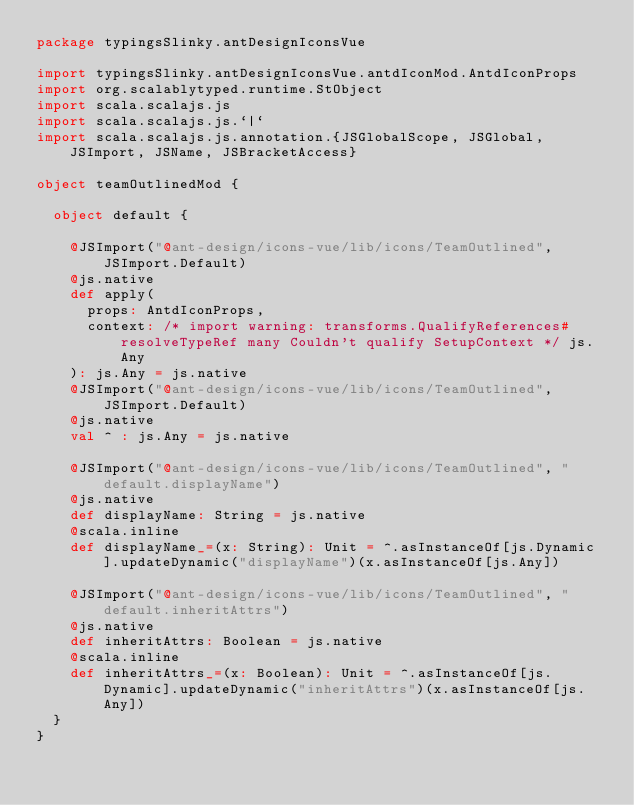Convert code to text. <code><loc_0><loc_0><loc_500><loc_500><_Scala_>package typingsSlinky.antDesignIconsVue

import typingsSlinky.antDesignIconsVue.antdIconMod.AntdIconProps
import org.scalablytyped.runtime.StObject
import scala.scalajs.js
import scala.scalajs.js.`|`
import scala.scalajs.js.annotation.{JSGlobalScope, JSGlobal, JSImport, JSName, JSBracketAccess}

object teamOutlinedMod {
  
  object default {
    
    @JSImport("@ant-design/icons-vue/lib/icons/TeamOutlined", JSImport.Default)
    @js.native
    def apply(
      props: AntdIconProps,
      context: /* import warning: transforms.QualifyReferences#resolveTypeRef many Couldn't qualify SetupContext */ js.Any
    ): js.Any = js.native
    @JSImport("@ant-design/icons-vue/lib/icons/TeamOutlined", JSImport.Default)
    @js.native
    val ^ : js.Any = js.native
    
    @JSImport("@ant-design/icons-vue/lib/icons/TeamOutlined", "default.displayName")
    @js.native
    def displayName: String = js.native
    @scala.inline
    def displayName_=(x: String): Unit = ^.asInstanceOf[js.Dynamic].updateDynamic("displayName")(x.asInstanceOf[js.Any])
    
    @JSImport("@ant-design/icons-vue/lib/icons/TeamOutlined", "default.inheritAttrs")
    @js.native
    def inheritAttrs: Boolean = js.native
    @scala.inline
    def inheritAttrs_=(x: Boolean): Unit = ^.asInstanceOf[js.Dynamic].updateDynamic("inheritAttrs")(x.asInstanceOf[js.Any])
  }
}
</code> 